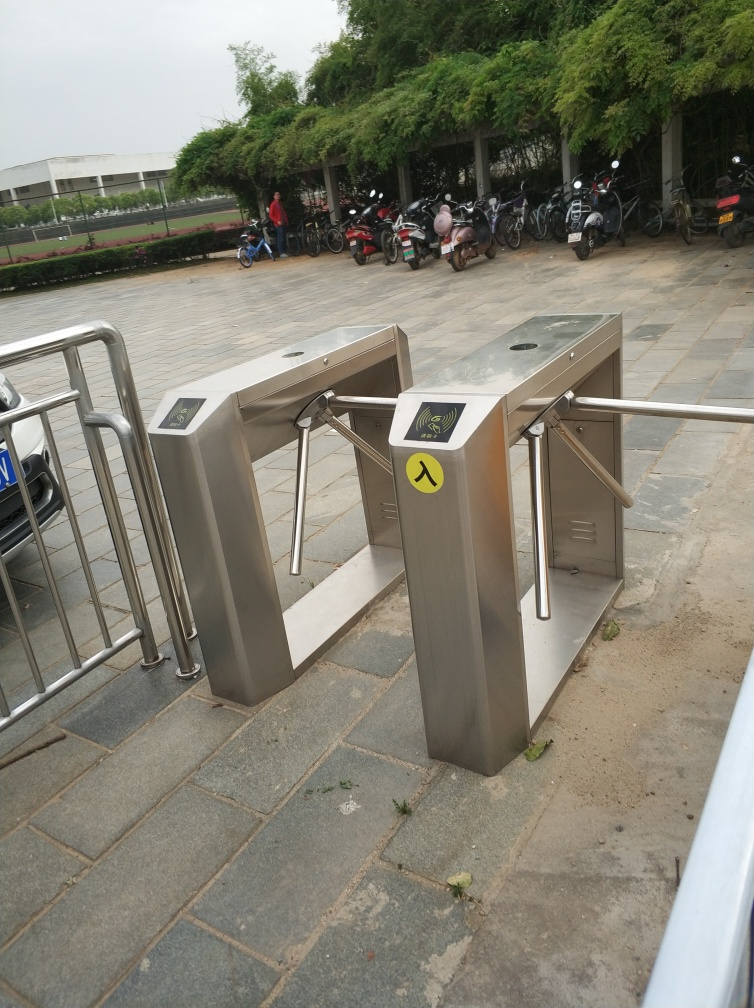Are there any quality issues with this image? Yes, there are several quality issues with the image. It is slightly tilted, which can give an unprofessional appearance. The focus is not centered on any particular subject, making the purpose of the image unclear. Moreover, the lighting conditions are overcast, resulting in a flat and muted color palette. The image could be improved by adjusting the angle, focusing on a more specific subject, and possibly enhancing the colors in post-processing to create a more visually appealing result. 